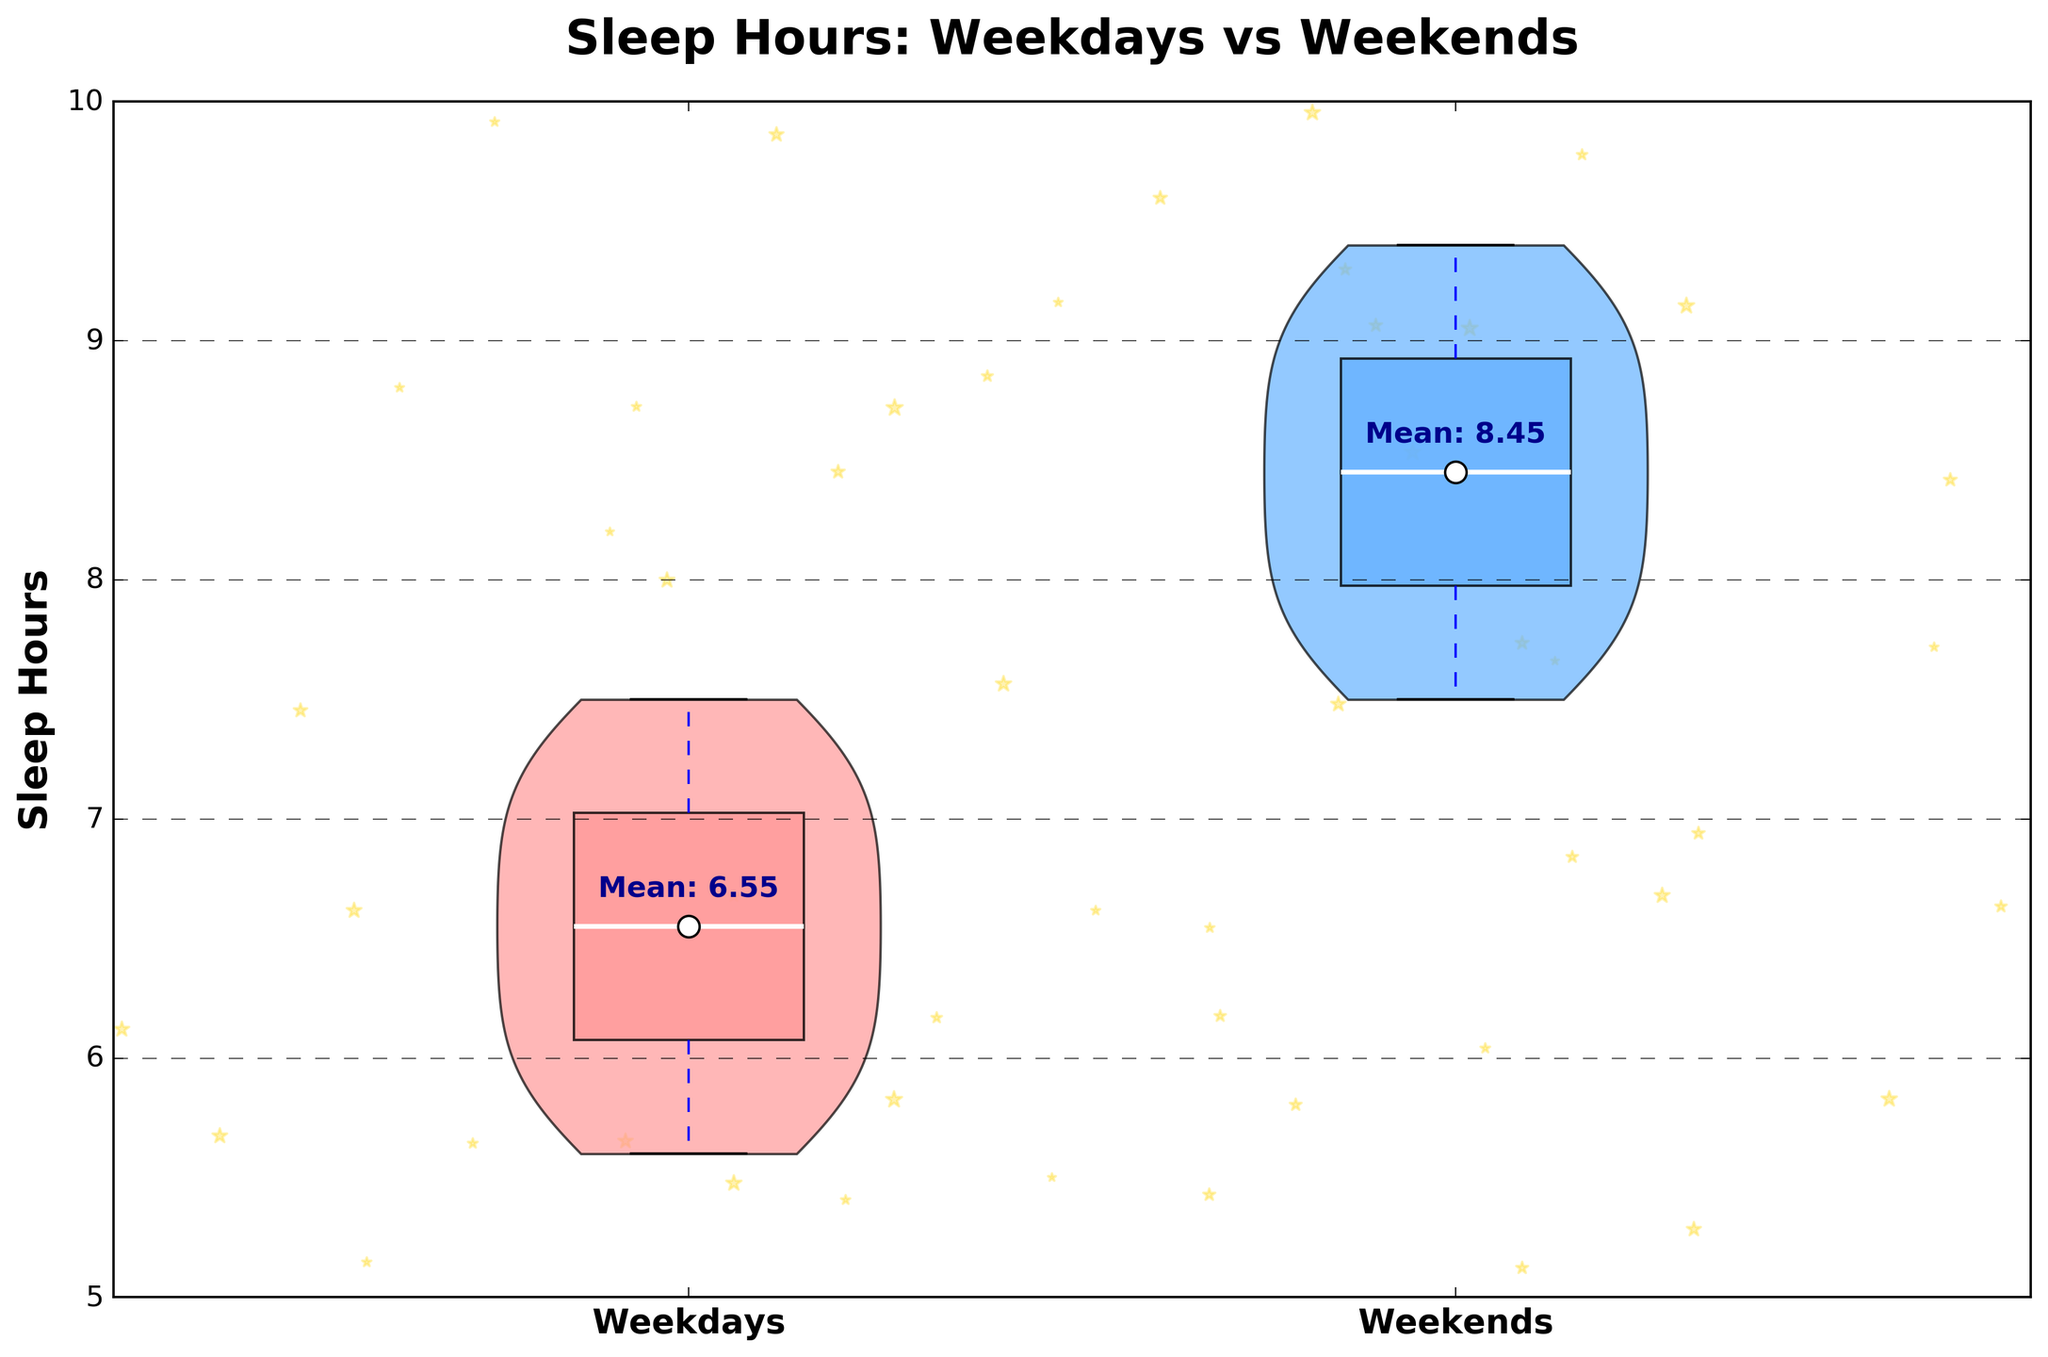what is the title of the plot? The title of the plot is displayed at the top, written in a large, bold font. It describes the data being visualized in the plot.
Answer: Sleep Hours: Weekdays vs Weekends What do the colors of the violins represent? The plot uses two different colors for the violins to represent different groups of data. The red color (left) is for Weekdays and the blue color (right) is for Weekends.
Answer: Weekdays and Weekends Which day category has a higher average sleep hours? The plot shows the average sleep hours as white dots with black edges on the violins. By comparing the positions of these dots, we can see that the average sleep hours for Weekends (blue) are higher than for Weekdays (red).
Answer: Weekends What is the specific average sleep hours for weekdays? The average sleep hours for weekdays can be seen as the white dot with a black edge on the red violin plot. The value is also annotated near the dot.
Answer: 6.54 What is the range of sleep hours for weekends? The range of sleep hours is represented by the spread of the blue violin plot. It extends from the lowest value to the highest value indicated on the y-axis.
Answer: Approximately 7.5 to 9.4 How do the median values of weekday and weekend sleep hours compare? The median values of sleep hours are indicated by the central lines inside the respective box plots within the violins. By comparing the positions of these lines, we can determine which is higher.
Answer: The median for Weekends is higher than for Weekdays How many students sleep between 6 and 7 hours on weekdays? The number of students is proportionate to the width of the violin plot in the range between 6 and 7 hours on the weekday violin. By observing the width in this range, we can estimate the number of students.
Answer: Looks like around 5-6 students What does the plot's background design represent? The background of the plot is adorned with star-like markers to give a creative touch that aligns with the theme of sleep and possibly dreaming, creating a night sky effect.
Answer: Stars in the background What is the annotation for the average sleep hours on weekends? The annotations are text labels near the white dots indicating the average sleep hours. For weekends, this annotation appears above the blue violin plot.
Answer: Mean: 8.50 